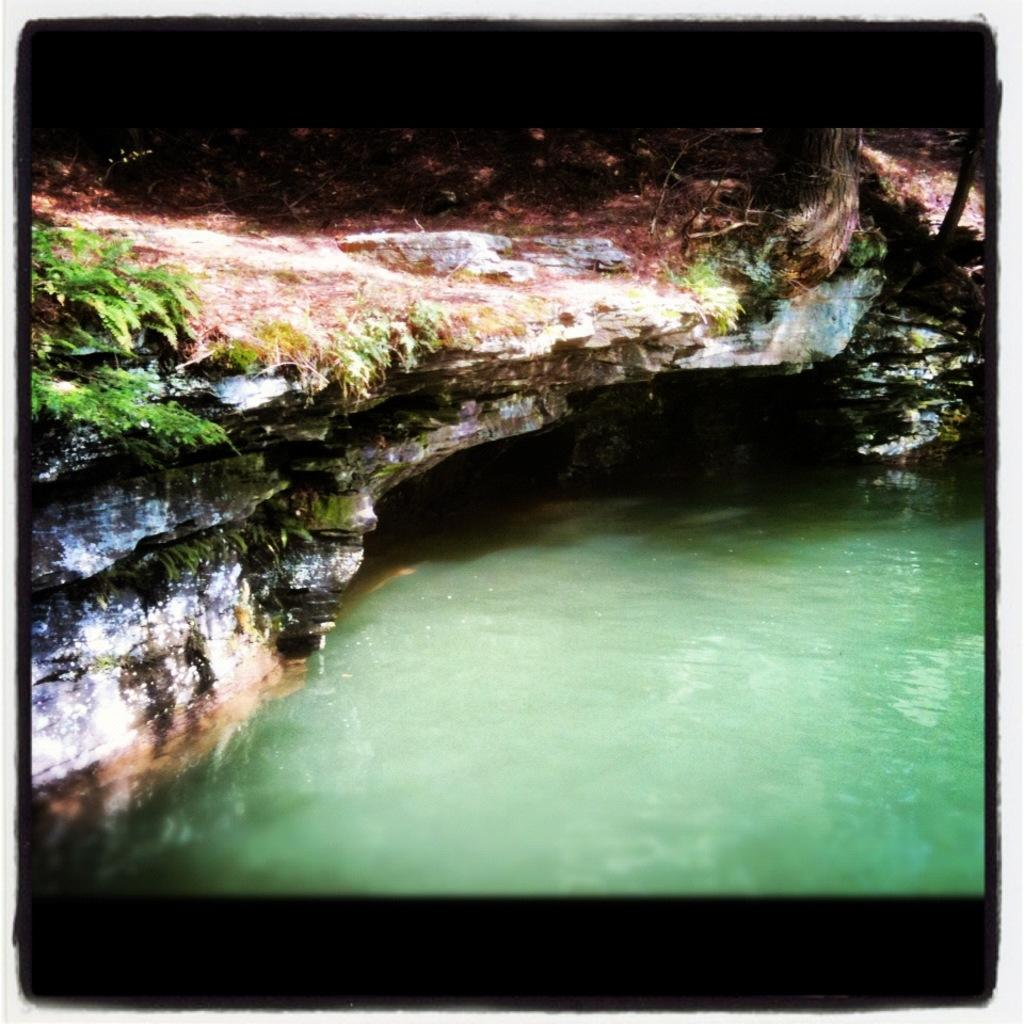What is in the foreground of the image? There is water in the foreground of the image. What type of vegetation can be seen in the image? There are plants and grass in the image. What part of a tree is visible in the image? The trunk of a tree is visible in the image. What other object can be found in the image? There is a rock in the image. How is the image framed? The image has a black border. Where is the scarecrow located in the image? There is no scarecrow present in the image. What type of fruit is the quince in the image? There is no quince present in the image. 